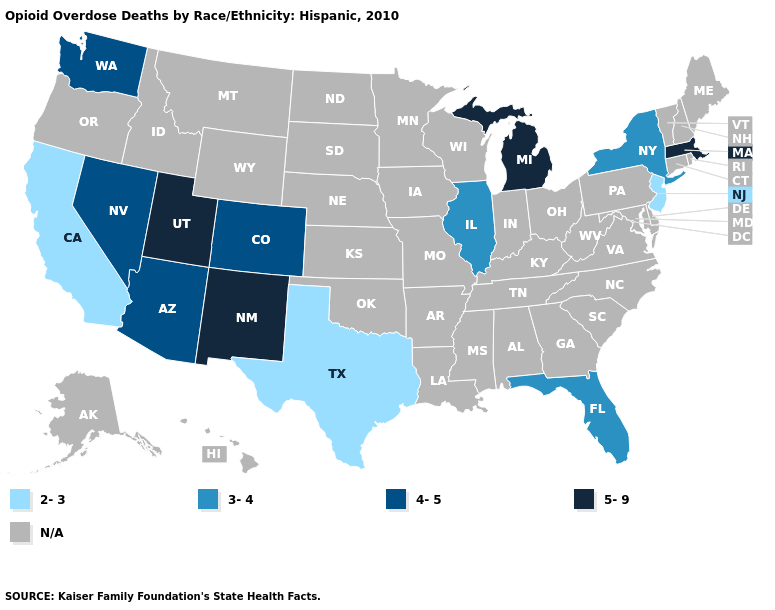Among the states that border Pennsylvania , which have the highest value?
Quick response, please. New York. What is the lowest value in the Northeast?
Answer briefly. 2-3. Name the states that have a value in the range 4-5?
Concise answer only. Arizona, Colorado, Nevada, Washington. How many symbols are there in the legend?
Answer briefly. 5. Which states have the lowest value in the USA?
Be succinct. California, New Jersey, Texas. Does the first symbol in the legend represent the smallest category?
Give a very brief answer. Yes. Name the states that have a value in the range 5-9?
Be succinct. Massachusetts, Michigan, New Mexico, Utah. What is the lowest value in states that border New Hampshire?
Keep it brief. 5-9. What is the value of Oklahoma?
Be succinct. N/A. Among the states that border Kansas , which have the highest value?
Concise answer only. Colorado. Which states have the lowest value in the USA?
Keep it brief. California, New Jersey, Texas. 